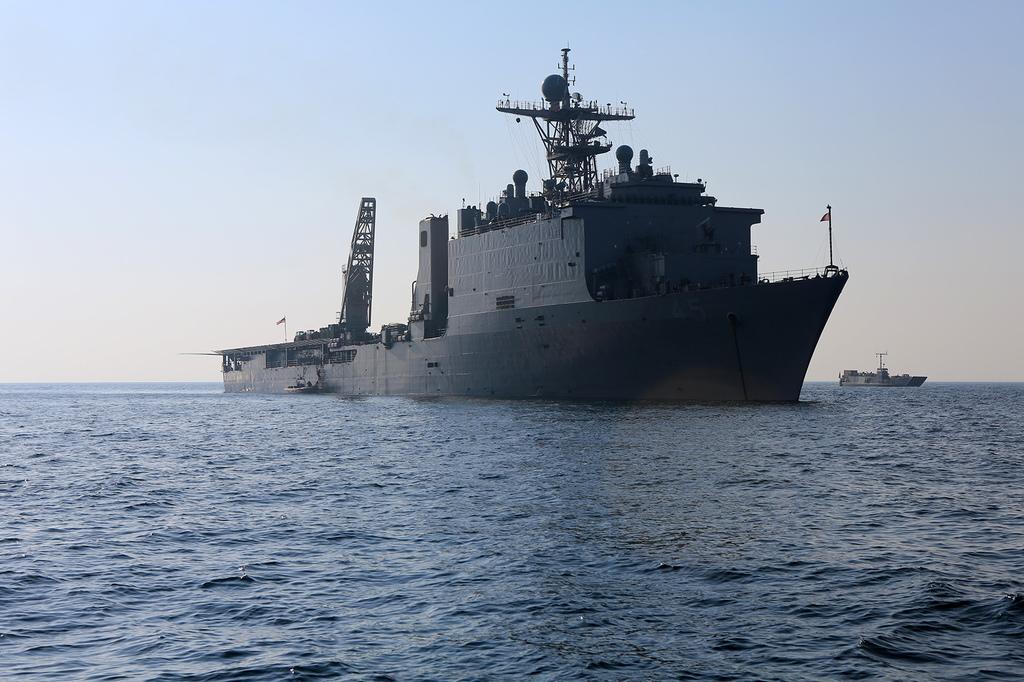Please provide a concise description of this image. In this picture we can see there are two ships on the water and on the ships there are poles. Behind the ships there is the sky. 